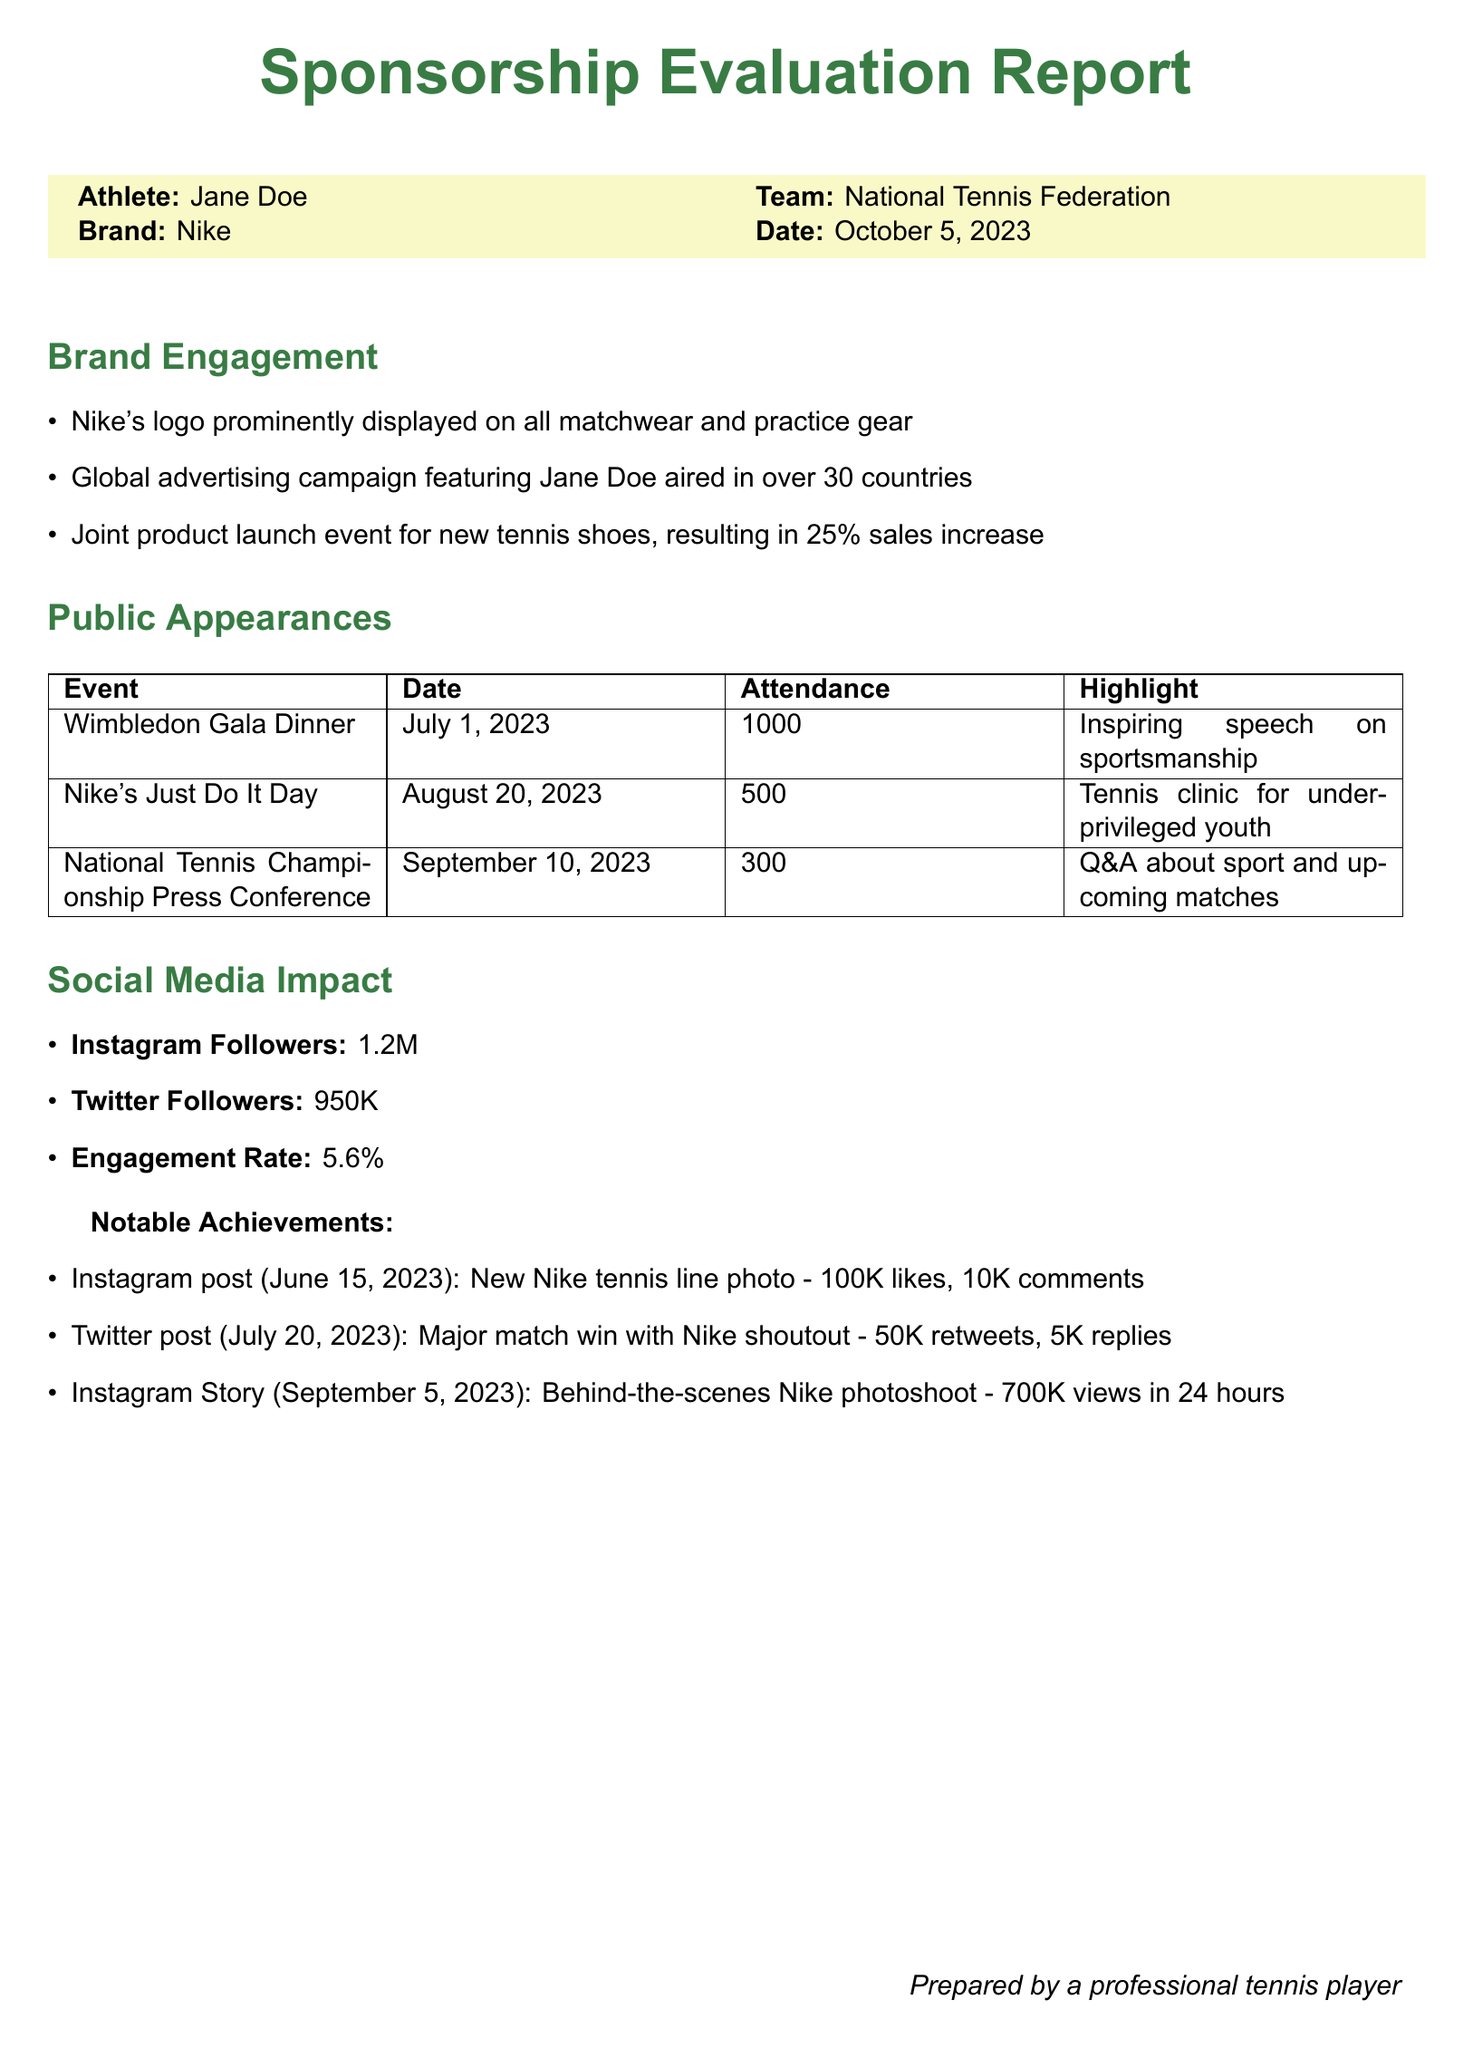What is the athlete's name? The athlete's name is explicitly mentioned in the report header as Jane Doe.
Answer: Jane Doe What brand is sponsoring the athlete? The brand sponsoring the athlete is indicated in the report header as Nike.
Answer: Nike How many countries aired the advertising campaign? The document states that the advertising campaign aired in over 30 countries.
Answer: 30 What was the attendance at the Wimbledon Gala Dinner? The attendance for the Wimbledon Gala Dinner is listed as 1000 participants.
Answer: 1000 What was the engagement rate on social media? The engagement rate is provided in the Social Media Impact section as 5.6 percent.
Answer: 5.6% What significant event occurred on August 20, 2023? The event noted for that date is Nike's Just Do It Day, featuring a tennis clinic for underprivileged youth.
Answer: Nike's Just Do It Day What was the highlight of the National Tennis Championship Press Conference? The highlight is mentioned as a Q&A about sport and upcoming matches.
Answer: Q&A about sport and upcoming matches How many Instagram followers does Jane Doe have? The document specifically states that Jane Doe has 1.2 million Instagram followers.
Answer: 1.2M What notable achievement received 700K views? The notable achievement is the Instagram Story from September 5, 2023, showing behind-the-scenes Nike photoshoot.
Answer: Behind-the-scenes Nike photoshoot 